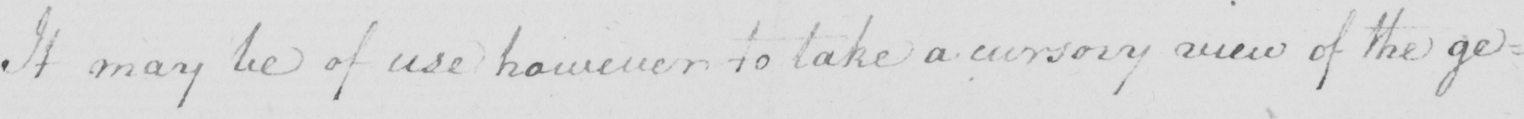Can you read and transcribe this handwriting? It may be of use however to take a cursory view of the ge= 